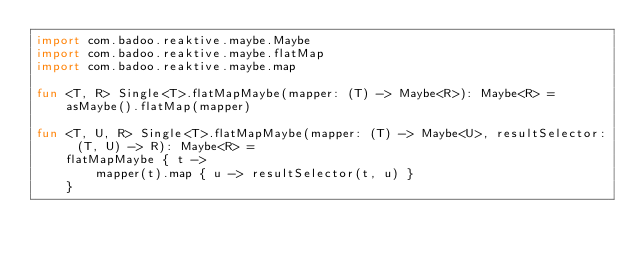<code> <loc_0><loc_0><loc_500><loc_500><_Kotlin_>import com.badoo.reaktive.maybe.Maybe
import com.badoo.reaktive.maybe.flatMap
import com.badoo.reaktive.maybe.map

fun <T, R> Single<T>.flatMapMaybe(mapper: (T) -> Maybe<R>): Maybe<R> =
    asMaybe().flatMap(mapper)

fun <T, U, R> Single<T>.flatMapMaybe(mapper: (T) -> Maybe<U>, resultSelector: (T, U) -> R): Maybe<R> =
    flatMapMaybe { t ->
        mapper(t).map { u -> resultSelector(t, u) }
    }</code> 